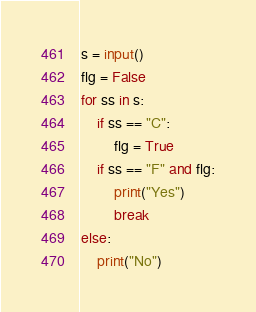<code> <loc_0><loc_0><loc_500><loc_500><_Python_>s = input()
flg = False
for ss in s:
    if ss == "C":
        flg = True
    if ss == "F" and flg:
        print("Yes")
        break
else:
    print("No")</code> 